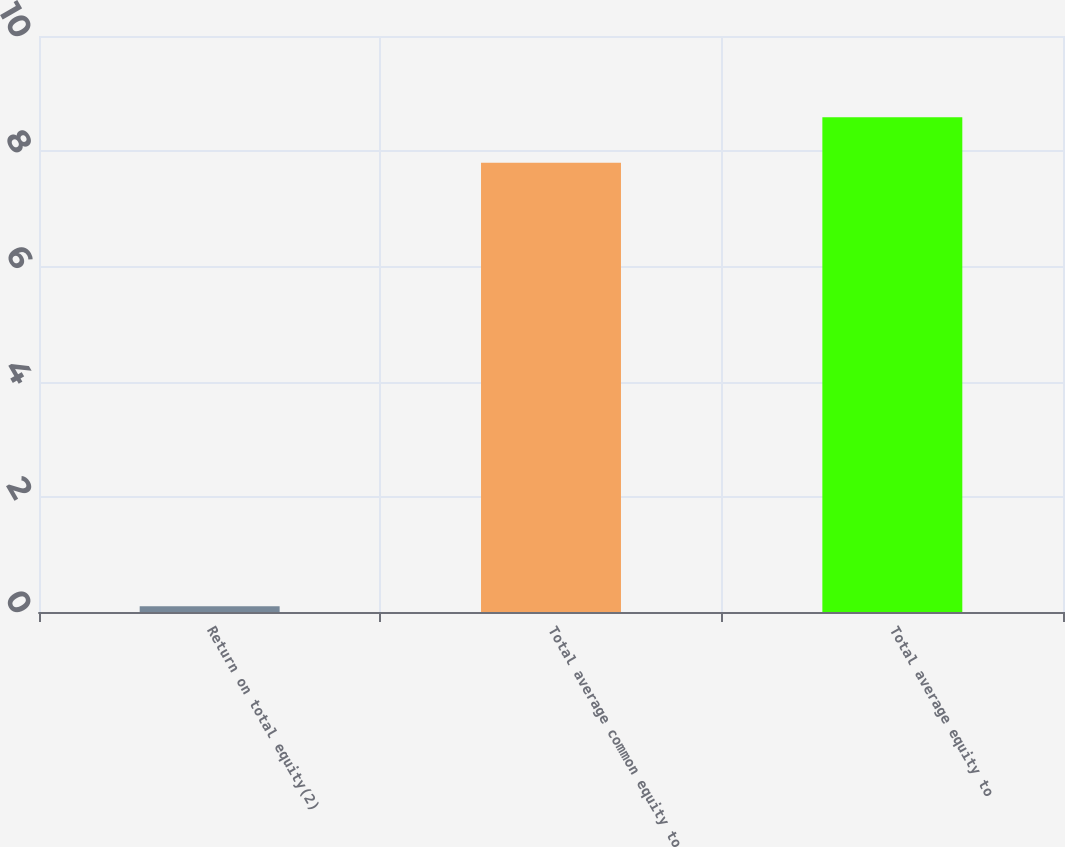<chart> <loc_0><loc_0><loc_500><loc_500><bar_chart><fcel>Return on total equity(2)<fcel>Total average common equity to<fcel>Total average equity to<nl><fcel>0.1<fcel>7.8<fcel>8.59<nl></chart> 